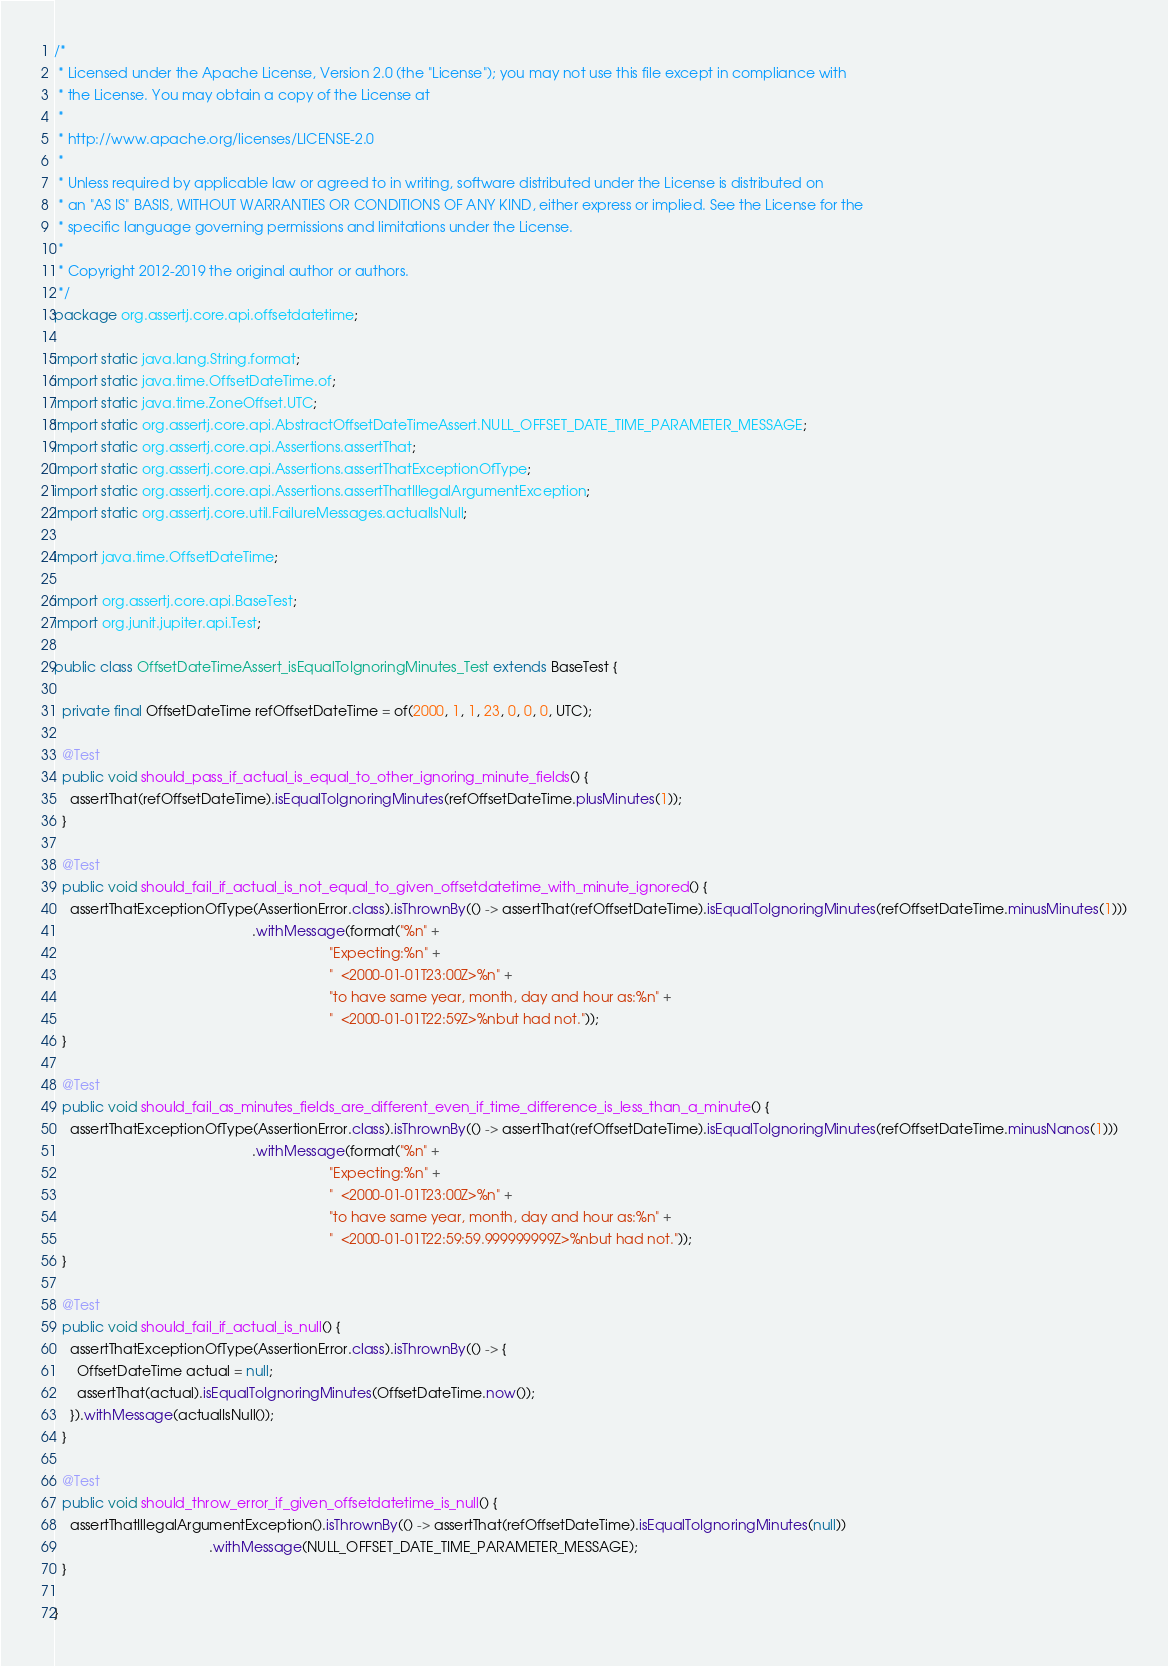<code> <loc_0><loc_0><loc_500><loc_500><_Java_>/*
 * Licensed under the Apache License, Version 2.0 (the "License"); you may not use this file except in compliance with
 * the License. You may obtain a copy of the License at
 *
 * http://www.apache.org/licenses/LICENSE-2.0
 *
 * Unless required by applicable law or agreed to in writing, software distributed under the License is distributed on
 * an "AS IS" BASIS, WITHOUT WARRANTIES OR CONDITIONS OF ANY KIND, either express or implied. See the License for the
 * specific language governing permissions and limitations under the License.
 *
 * Copyright 2012-2019 the original author or authors.
 */
package org.assertj.core.api.offsetdatetime;

import static java.lang.String.format;
import static java.time.OffsetDateTime.of;
import static java.time.ZoneOffset.UTC;
import static org.assertj.core.api.AbstractOffsetDateTimeAssert.NULL_OFFSET_DATE_TIME_PARAMETER_MESSAGE;
import static org.assertj.core.api.Assertions.assertThat;
import static org.assertj.core.api.Assertions.assertThatExceptionOfType;
import static org.assertj.core.api.Assertions.assertThatIllegalArgumentException;
import static org.assertj.core.util.FailureMessages.actualIsNull;

import java.time.OffsetDateTime;

import org.assertj.core.api.BaseTest;
import org.junit.jupiter.api.Test;

public class OffsetDateTimeAssert_isEqualToIgnoringMinutes_Test extends BaseTest {

  private final OffsetDateTime refOffsetDateTime = of(2000, 1, 1, 23, 0, 0, 0, UTC);

  @Test
  public void should_pass_if_actual_is_equal_to_other_ignoring_minute_fields() {
    assertThat(refOffsetDateTime).isEqualToIgnoringMinutes(refOffsetDateTime.plusMinutes(1));
  }

  @Test
  public void should_fail_if_actual_is_not_equal_to_given_offsetdatetime_with_minute_ignored() {
    assertThatExceptionOfType(AssertionError.class).isThrownBy(() -> assertThat(refOffsetDateTime).isEqualToIgnoringMinutes(refOffsetDateTime.minusMinutes(1)))
                                                   .withMessage(format("%n" +
                                                                       "Expecting:%n" +
                                                                       "  <2000-01-01T23:00Z>%n" +
                                                                       "to have same year, month, day and hour as:%n" +
                                                                       "  <2000-01-01T22:59Z>%nbut had not."));
  }

  @Test
  public void should_fail_as_minutes_fields_are_different_even_if_time_difference_is_less_than_a_minute() {
    assertThatExceptionOfType(AssertionError.class).isThrownBy(() -> assertThat(refOffsetDateTime).isEqualToIgnoringMinutes(refOffsetDateTime.minusNanos(1)))
                                                   .withMessage(format("%n" +
                                                                       "Expecting:%n" +
                                                                       "  <2000-01-01T23:00Z>%n" +
                                                                       "to have same year, month, day and hour as:%n" +
                                                                       "  <2000-01-01T22:59:59.999999999Z>%nbut had not."));
  }

  @Test
  public void should_fail_if_actual_is_null() {
    assertThatExceptionOfType(AssertionError.class).isThrownBy(() -> {
      OffsetDateTime actual = null;
      assertThat(actual).isEqualToIgnoringMinutes(OffsetDateTime.now());
    }).withMessage(actualIsNull());
  }

  @Test
  public void should_throw_error_if_given_offsetdatetime_is_null() {
    assertThatIllegalArgumentException().isThrownBy(() -> assertThat(refOffsetDateTime).isEqualToIgnoringMinutes(null))
                                        .withMessage(NULL_OFFSET_DATE_TIME_PARAMETER_MESSAGE);
  }

}
</code> 